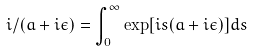<formula> <loc_0><loc_0><loc_500><loc_500>i / ( a + i \epsilon ) = \int _ { 0 } ^ { \infty } \exp [ i s ( a + i \epsilon ) ] d s</formula> 